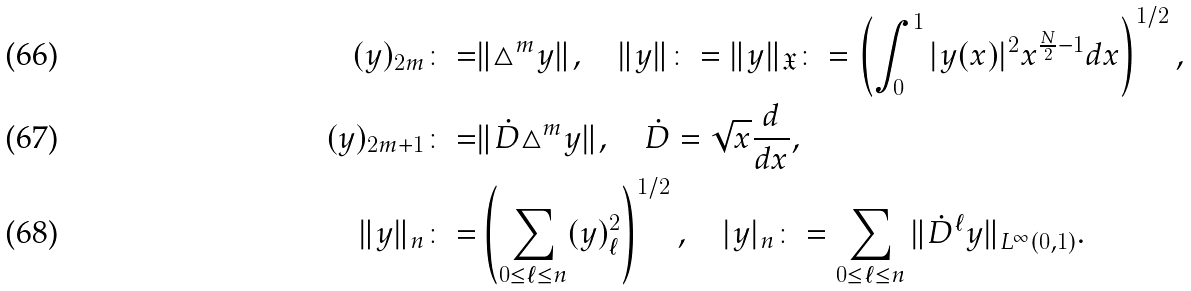Convert formula to latex. <formula><loc_0><loc_0><loc_500><loc_500>( y ) _ { 2 m } \colon = & \| \triangle ^ { m } y \| , \quad \| y \| \colon = \| y \| _ { \mathfrak { X } } \colon = \left ( \int _ { 0 } ^ { 1 } | y ( x ) | ^ { 2 } x ^ { \frac { N } { 2 } - 1 } d x \right ) ^ { 1 / 2 } , \\ ( y ) _ { 2 m + 1 } \colon = & \| \dot { D } \triangle ^ { m } y \| , \quad \dot { D } = \sqrt { x } \frac { d } { d x } , \\ \| y \| _ { n } \colon = & \left ( \sum _ { 0 \leq \ell \leq n } ( y ) _ { \ell } ^ { 2 } \right ) ^ { 1 / 2 } , \quad | y | _ { n } \colon = \sum _ { 0 \leq \ell \leq n } \| \dot { D } ^ { \ell } y \| _ { L ^ { \infty } ( 0 , 1 ) } .</formula> 